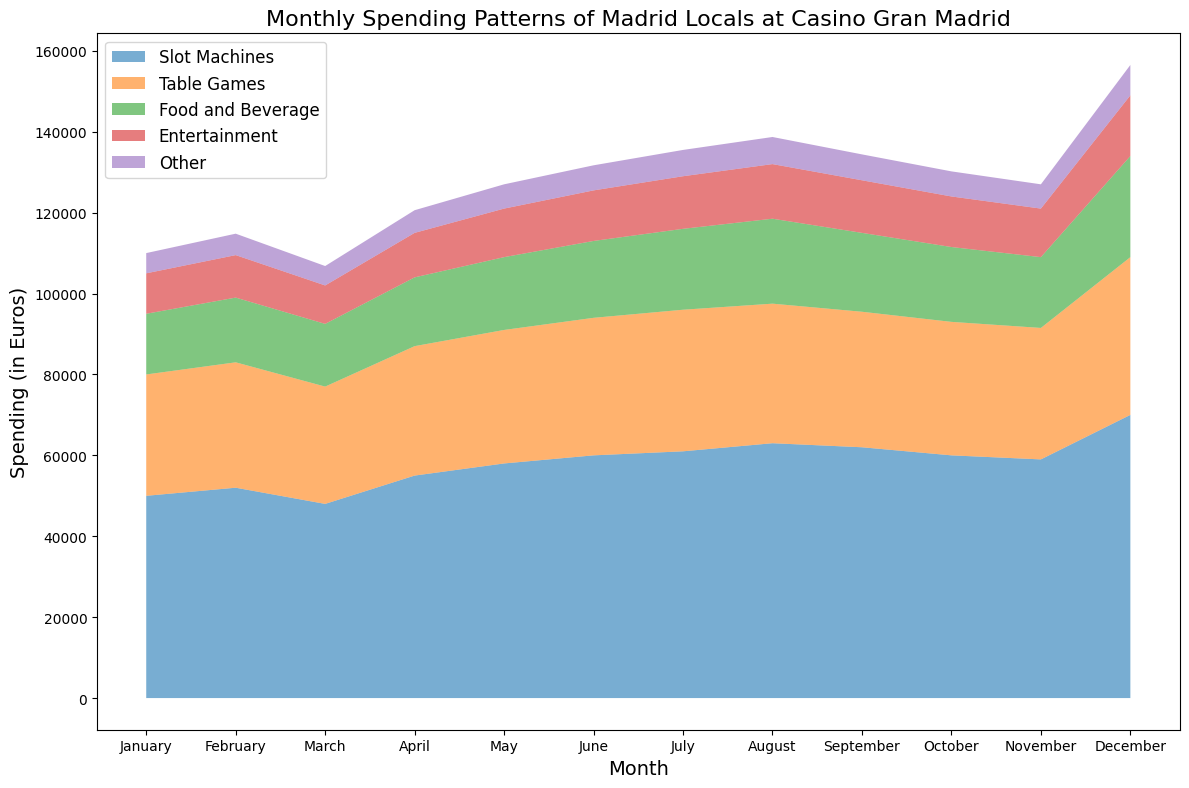What's the overall trend in spending on Slot Machines from January to December? Visually inspect the area representing Slot Machines. The height of this area increases consistently from January to December, with the most significant increase in December.
Answer: Increasing trend Which month had the highest combined spending on Table Games and Food and Beverage? Add the height of the Table Games and Food and Beverage areas for each month. In December, both areas are notably larger compared to other months, indicating the highest combined spending.
Answer: December How does the spending on Entertainment in July compare to that in September? Compare the heights of the Entertainment area between July and September. The height in July is slightly greater than in September.
Answer: Higher in July By how much does the spending on Other in December differ from that in January? Subtract the January spending on Other from the December spending on Other (7500 - 5000). The difference is 2500 euros.
Answer: 2500 euros more Which category had the most spending in November? Look at the different sections in November and assess their heights. The Slot Machines area is the largest in November, indicating the highest spending.
Answer: Slot Machines What was the total spending for Table Games in March? The Table Games area starts from the top of the Slot Machines and is slightly above the March level. The spending value can be directly referenced from the data.
Answer: 29000 euros How did the spending on Food and Beverage change from August to October? Observe the area of Food and Beverage between August and October. The area decreases slightly, indicating reduced spending.
Answer: Decreased What's the average monthly spending on Entertainment across the year? Sum up the monthly spending on Entertainment and divide by 12: (10000+10500+9500+11000+12000+12500+13000+13500+13000+12500+12000+15000)/12 = 11750.
Answer: 11750 euros Which month had the lowest total spending among all categories combined? Look for the month with the smallest overall area representing all categories combined. March has the smallest combined area.
Answer: March How much more was the spending on Slot Machines in December compared to February? Subtract the February spending on Slot Machines from the December amount: (70000 - 52000). The difference is 18000 euros.
Answer: 18000 euros more 